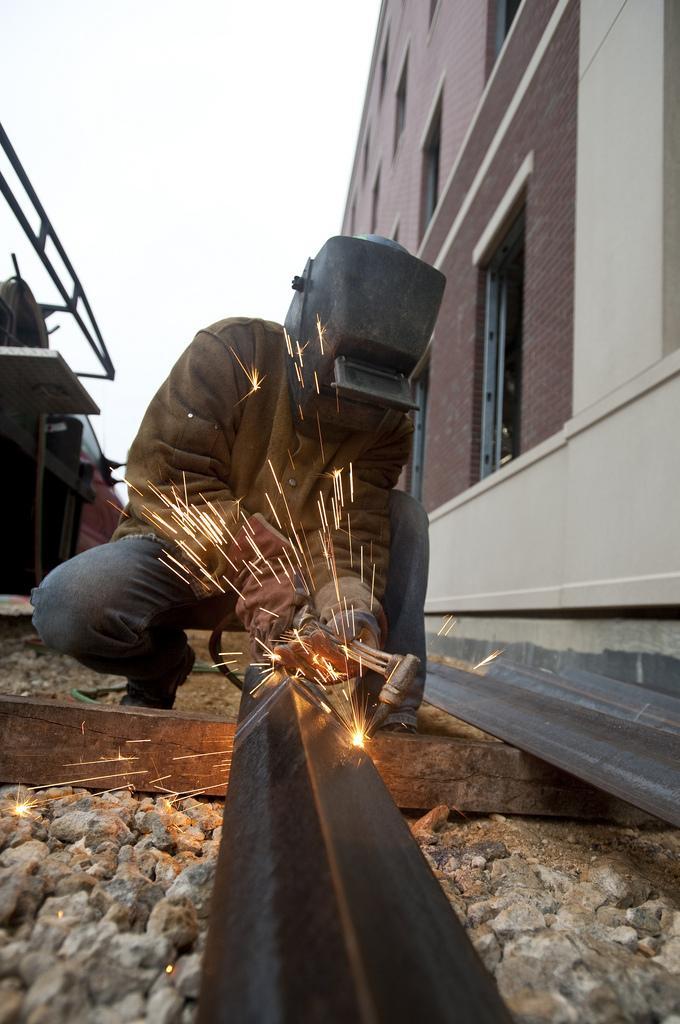Describe this image in one or two sentences. In this image there is a person welding an iron rod, on the left there is a house, on the right there are some tables, in the background there is a sky. 